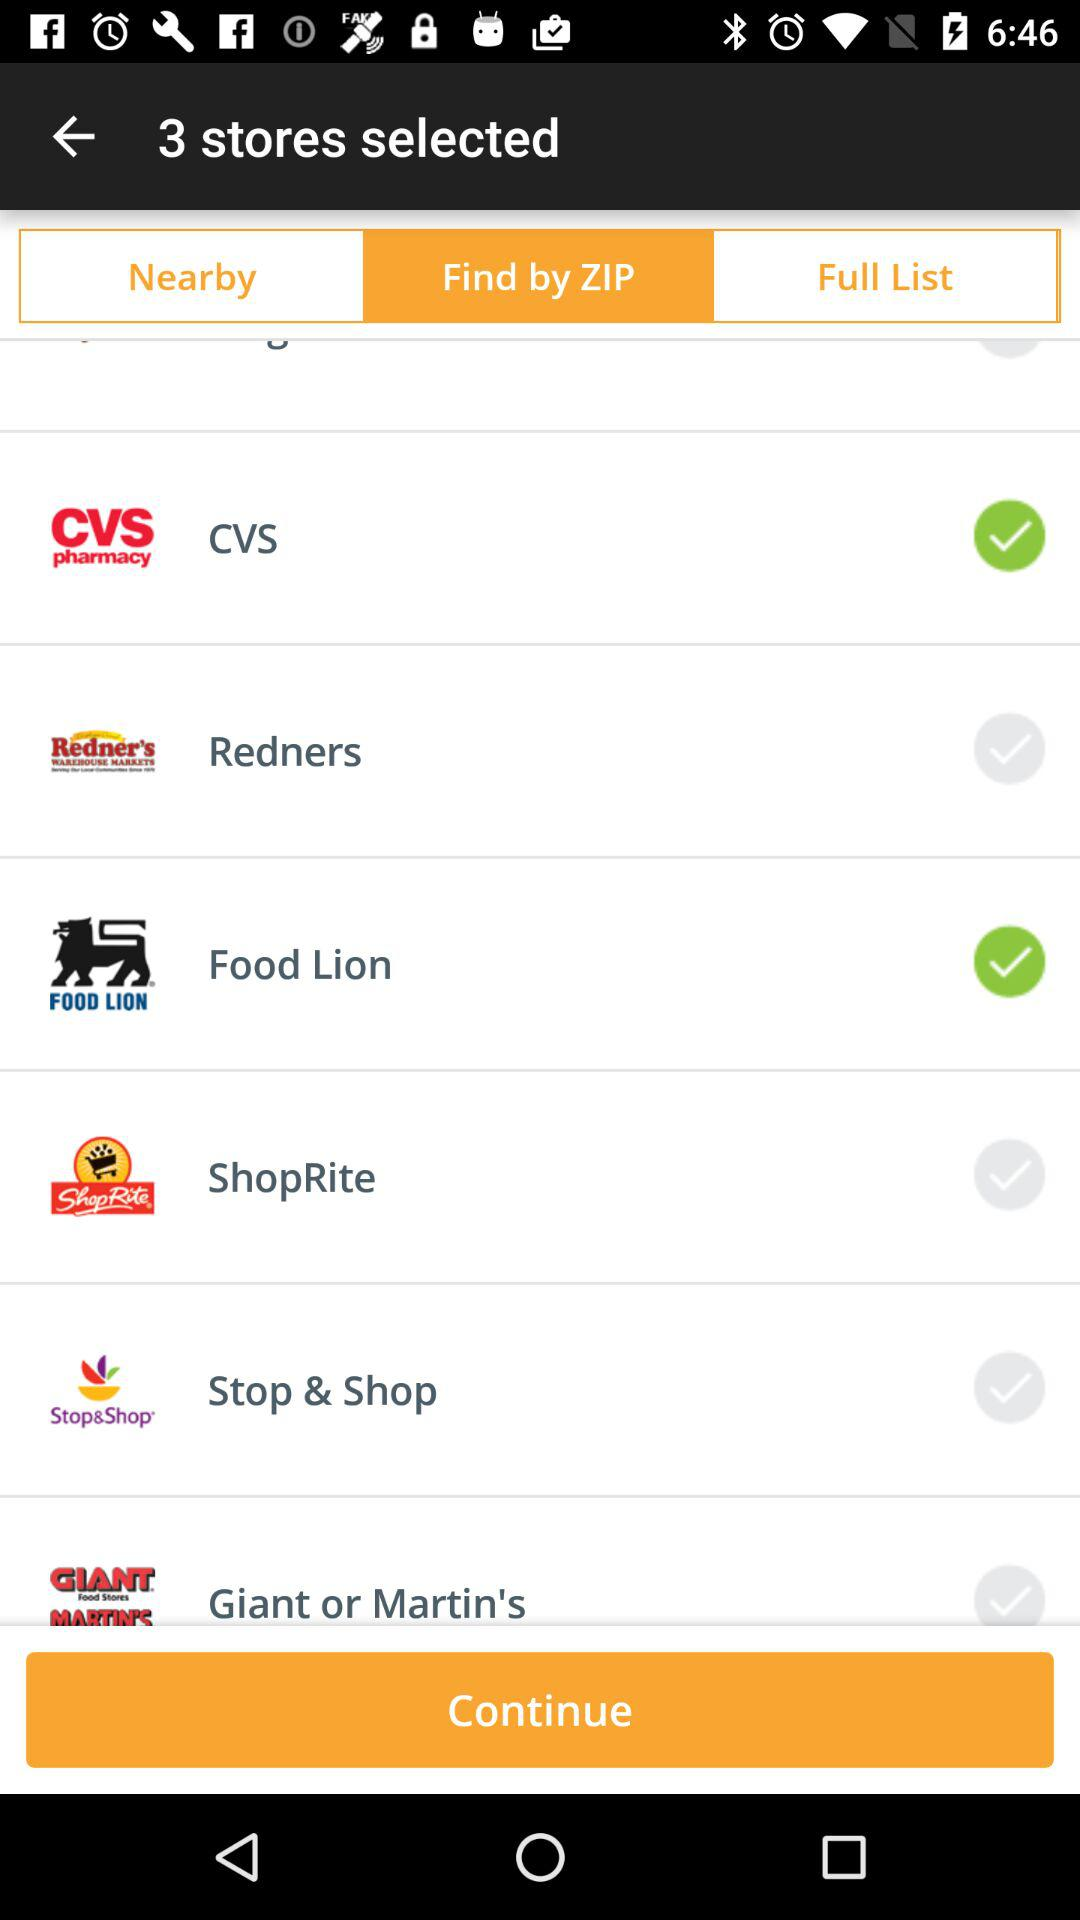Which store has a lion symbol in its logo? The store that has a lion symbol in its logo is "Food Lion". 